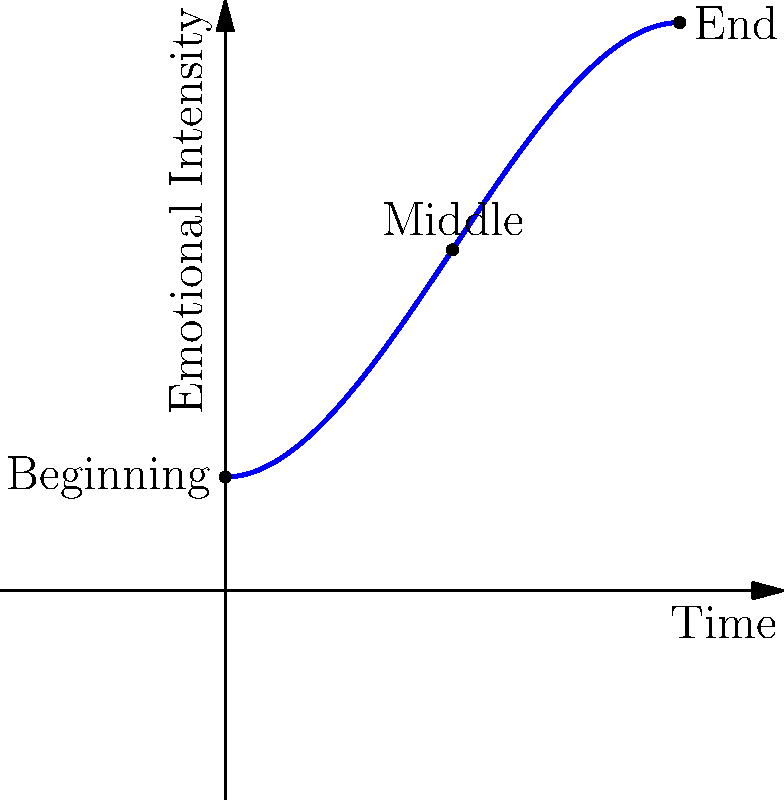In your role as a creative writing lecturer, you've designed an exercise to help students visualize the emotional arc of a story using a coordinate system. The x-axis represents time (from the beginning to the end of the story), and the y-axis represents emotional intensity. Given the curve shown in the graph, which represents a typical emotional arc, at which point does the story reach its highest emotional intensity? Express your answer as an ordered pair $(x,y)$, where $x$ is the time coordinate and $y$ is the emotional intensity coordinate, rounded to two decimal places. To find the point of highest emotional intensity, we need to follow these steps:

1. Recognize that the highest point on the curve represents the highest emotional intensity.

2. Visually inspect the graph to estimate where this peak occurs. It appears to be slightly after the midpoint of the story.

3. To find the exact point, we need to find the maximum of the function. The curve is represented by the function:

   $f(x) = -0.5x^3 + 1.5x^2 + 0.5$

4. To find the maximum, we need to find where the derivative of this function equals zero:

   $f'(x) = -1.5x^2 + 3x$

5. Set this equal to zero and solve:

   $-1.5x^2 + 3x = 0$
   $x(-1.5x + 3) = 0$
   $x = 0$ or $x = 2$

6. $x = 0$ is the beginning of the story, which is clearly not the maximum. Therefore, the maximum occurs at $x = 2$.

7. To find the y-coordinate, we plug $x = 2$ into our original function:

   $f(2) = -0.5(2)^3 + 1.5(2)^2 + 0.5 = -4 + 6 + 0.5 = 2.5$

8. Therefore, the point of highest emotional intensity is $(2, 2.5)$.
Answer: $(2, 2.5)$ 